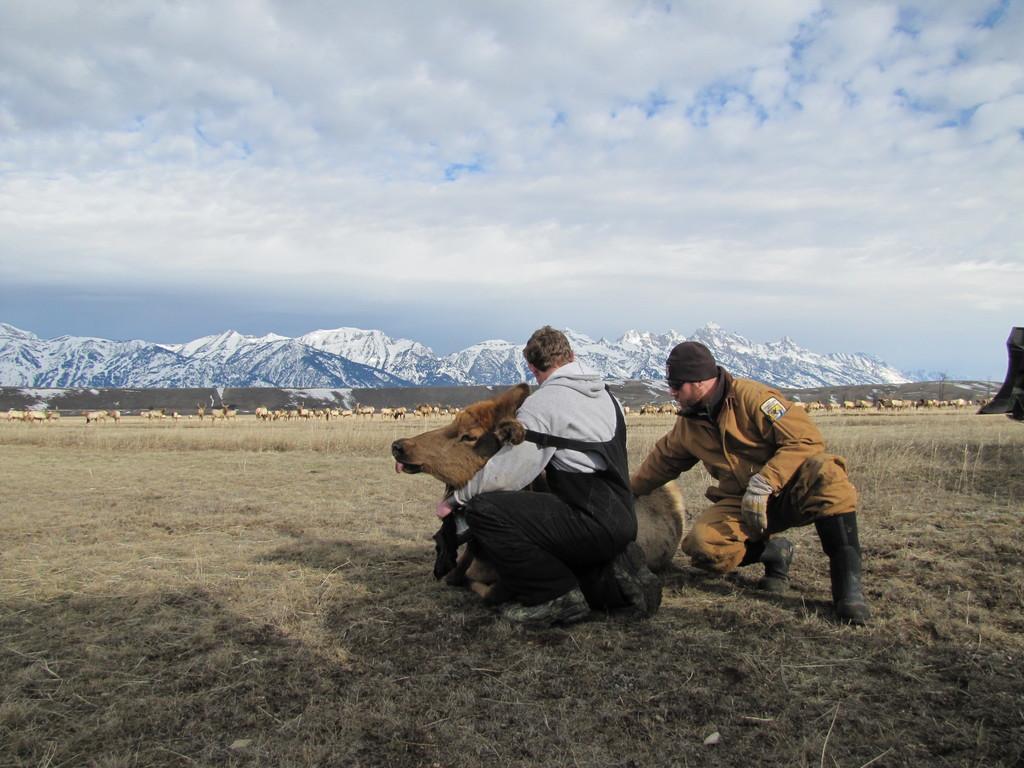Please provide a concise description of this image. There are two people sitting like squat position and we can see animal on grass. Background we can see animals,hills and sky. 